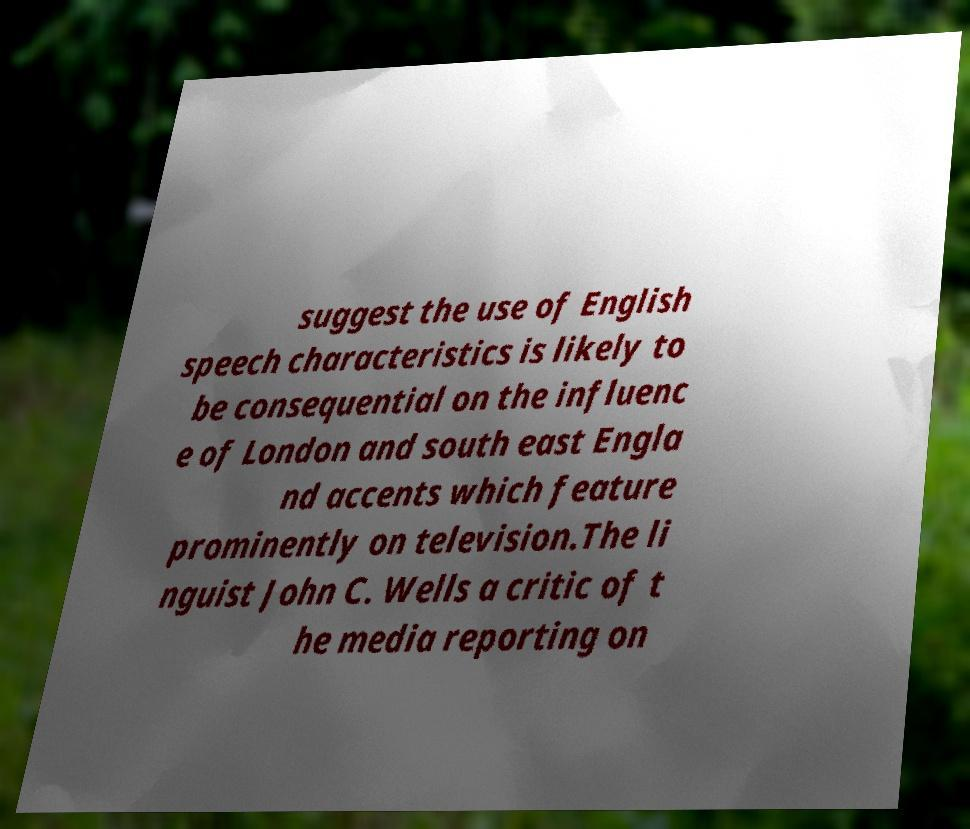Can you read and provide the text displayed in the image?This photo seems to have some interesting text. Can you extract and type it out for me? suggest the use of English speech characteristics is likely to be consequential on the influenc e of London and south east Engla nd accents which feature prominently on television.The li nguist John C. Wells a critic of t he media reporting on 